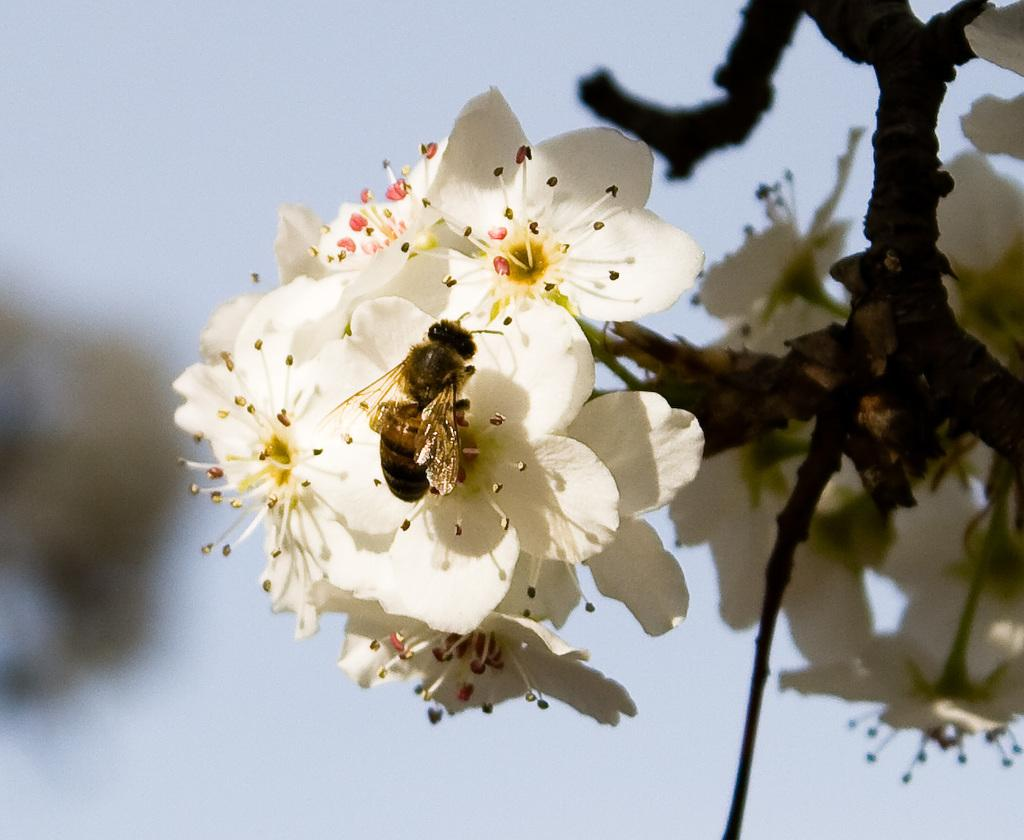What is present on the flower in the image? There is an insect on a flower in the image. What color is the flower that the insect is on? The flower is white in color. What type of plant is visible in the image? There is a flower plant in the image. How would you describe the background of the image? The background of the image is blurred. Where is the jail located in the image? There is no jail present in the image. What type of vest is the insect wearing in the image? Insects do not wear vests, and there is no vest present in the image. 